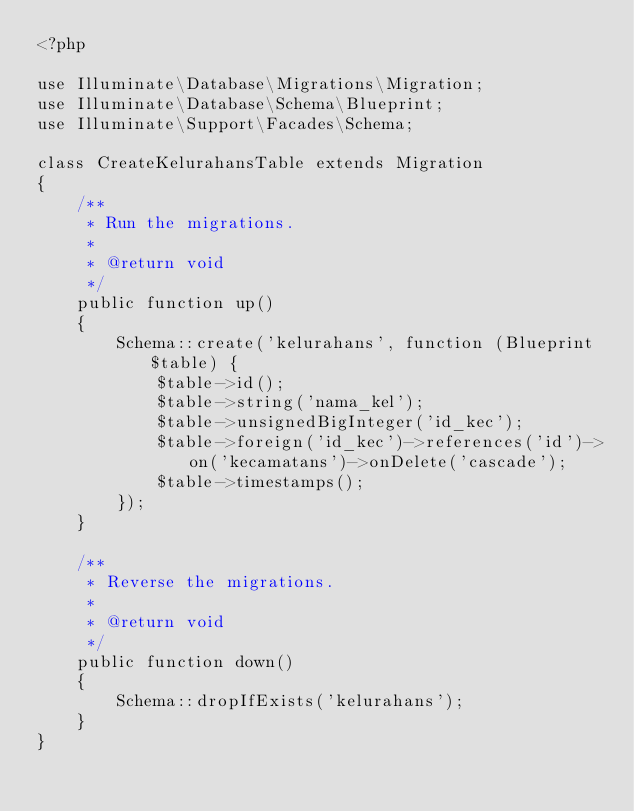<code> <loc_0><loc_0><loc_500><loc_500><_PHP_><?php

use Illuminate\Database\Migrations\Migration;
use Illuminate\Database\Schema\Blueprint;
use Illuminate\Support\Facades\Schema;

class CreateKelurahansTable extends Migration
{
    /**
     * Run the migrations.
     *
     * @return void
     */
    public function up()
    {
        Schema::create('kelurahans', function (Blueprint $table) {
            $table->id();
            $table->string('nama_kel');
            $table->unsignedBigInteger('id_kec');
            $table->foreign('id_kec')->references('id')->on('kecamatans')->onDelete('cascade');
            $table->timestamps();
        });
    }

    /**
     * Reverse the migrations.
     *
     * @return void
     */
    public function down()
    {
        Schema::dropIfExists('kelurahans');
    }
}
</code> 